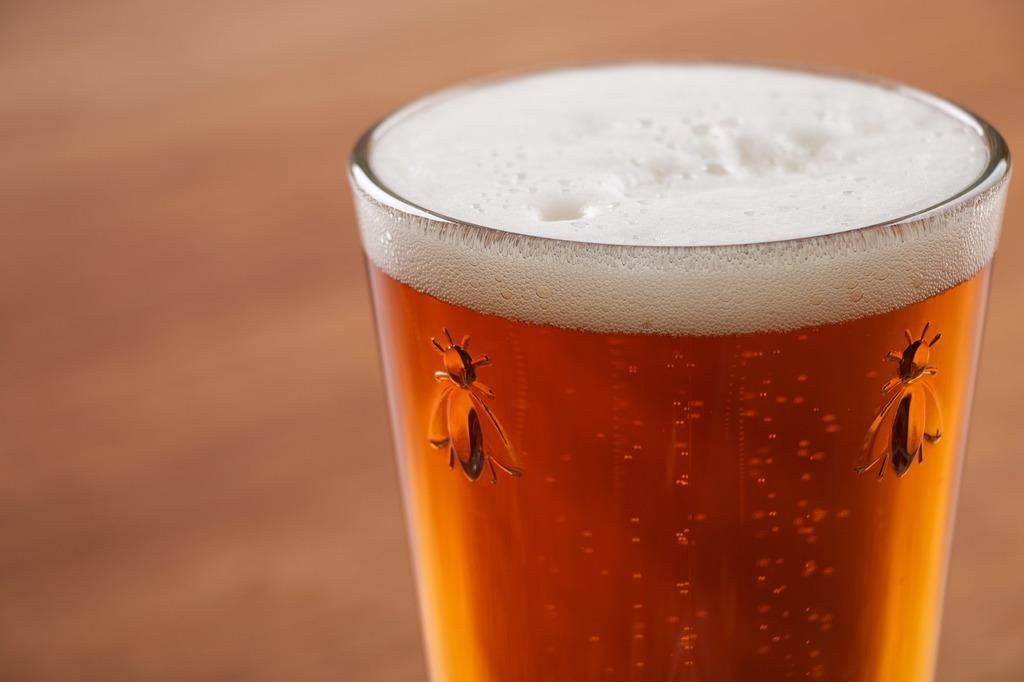What object is present in the image that can hold a liquid? There is a glass in the image that can hold a liquid. What is inside the glass in the image? The glass contains a drink. Can you describe the background of the image? The background of the image is blurred. What title is given to the drink in the glass? There is no title given to the drink in the glass in the image. How does the drink in the glass affect the temper of the person holding the glass? The image does not provide any information about the person holding the glass or their temper. 